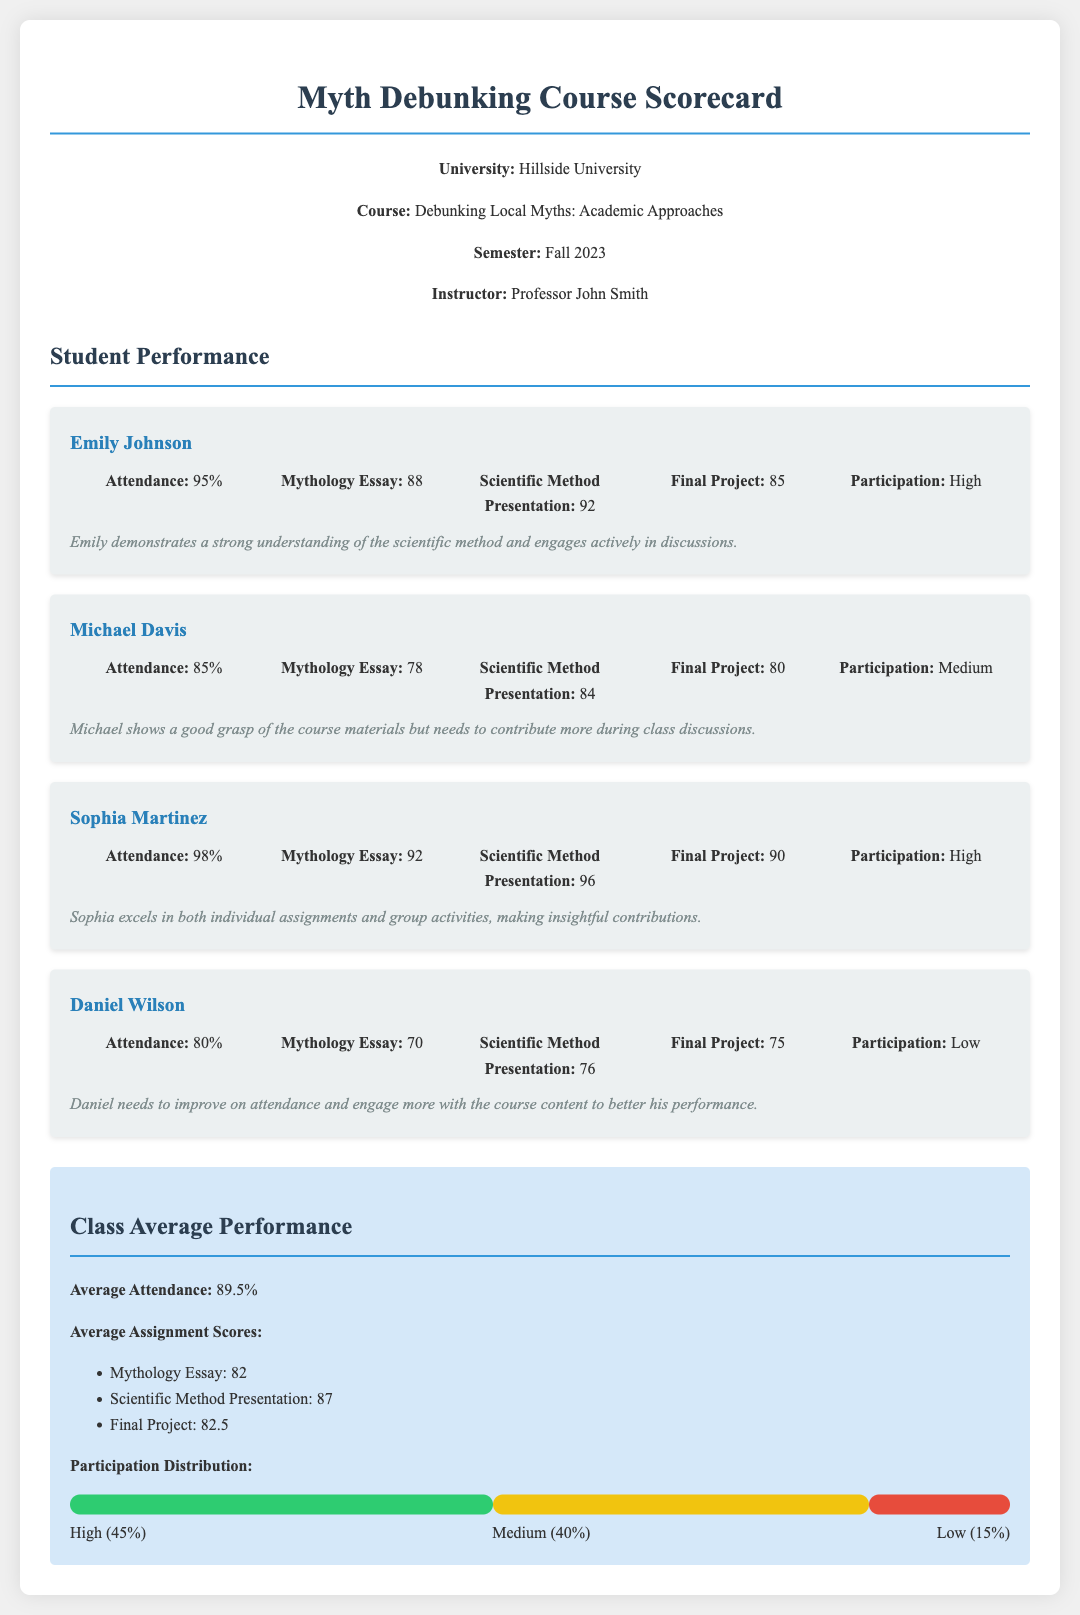What is the average attendance of the class? The average attendance is calculated based on the attendance percentages of all students listed in the document, which totals to 89.5%.
Answer: 89.5% Who is the instructor of the course? The instructor's name is mentioned in the header section of the document, which is Professor John Smith.
Answer: Professor John Smith What percentage of students had high participation? The participation distribution shows that 45% of students had high participation.
Answer: 45% What is the score of Sophia Martinez for the Scientific Method Presentation? The document provides the score for the Scientific Method Presentation specifically for Sophia Martinez, which is 96.
Answer: 96 How many students have a participation level of Medium? The participation distribution data indicates that 40% of students fall under the Medium category.
Answer: 40% What is Daniel Wilson's attendance percentage? Daniel Wilson's attendance is explicitly stated in his student card, which is 80%.
Answer: 80% What score did Michael Davis receive for his Mythology Essay? The performance data for Michael Davis includes a score of 78 for the Mythology Essay.
Answer: 78 What is the average score for the Final Project in the class? The class average for the Final Project is calculated and noted as 82.5 in the document.
Answer: 82.5 What is Emily Johnson's score on the Final Project? Emily Johnson's score for the Final Project is provided directly in the student card as 85.
Answer: 85 